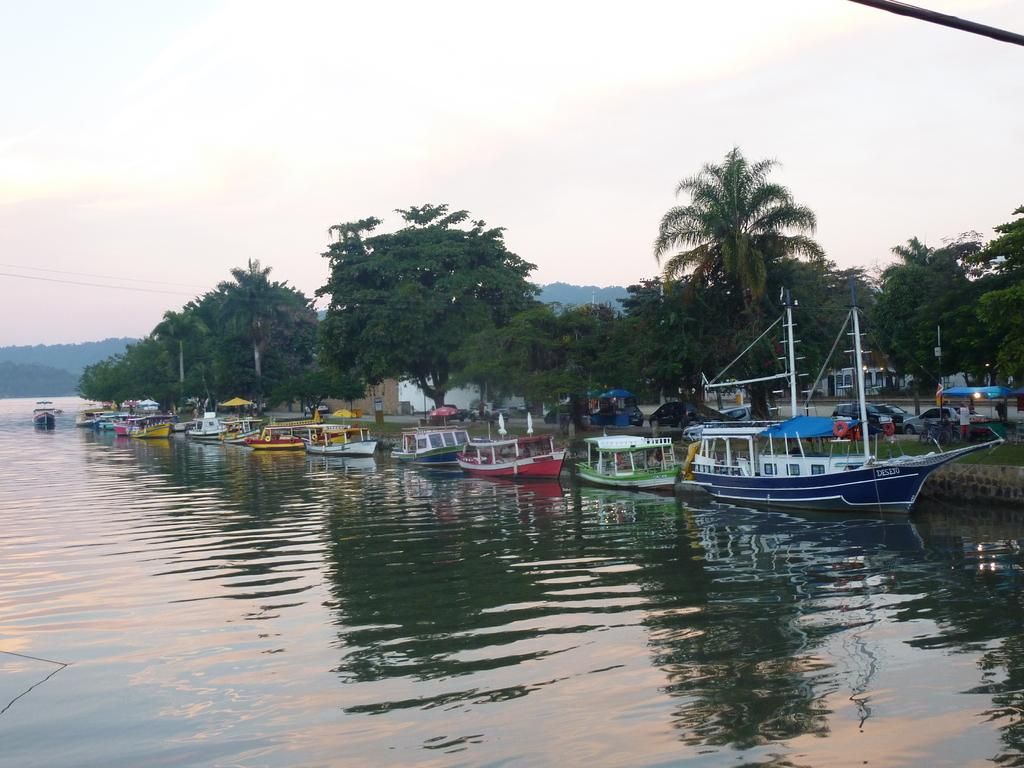What is floating in the water in the image? There is a group of boats floating in the water in the image. What else can be seen besides the boats in the image? There are vehicles, buildings, and a group of trees visible in the image. What is the condition of the sky in the image? The sky is visible in the image and appears cloudy. What type of shoe is visible in the image? There is no shoe present in the image. What type of army is depicted in the image? There is no army or military presence in the image. 